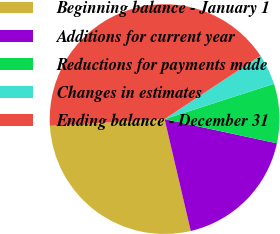<chart> <loc_0><loc_0><loc_500><loc_500><pie_chart><fcel>Beginning balance - January 1<fcel>Additions for current year<fcel>Reductions for payments made<fcel>Changes in estimates<fcel>Ending balance - December 31<nl><fcel>27.72%<fcel>17.97%<fcel>8.35%<fcel>4.32%<fcel>41.65%<nl></chart> 